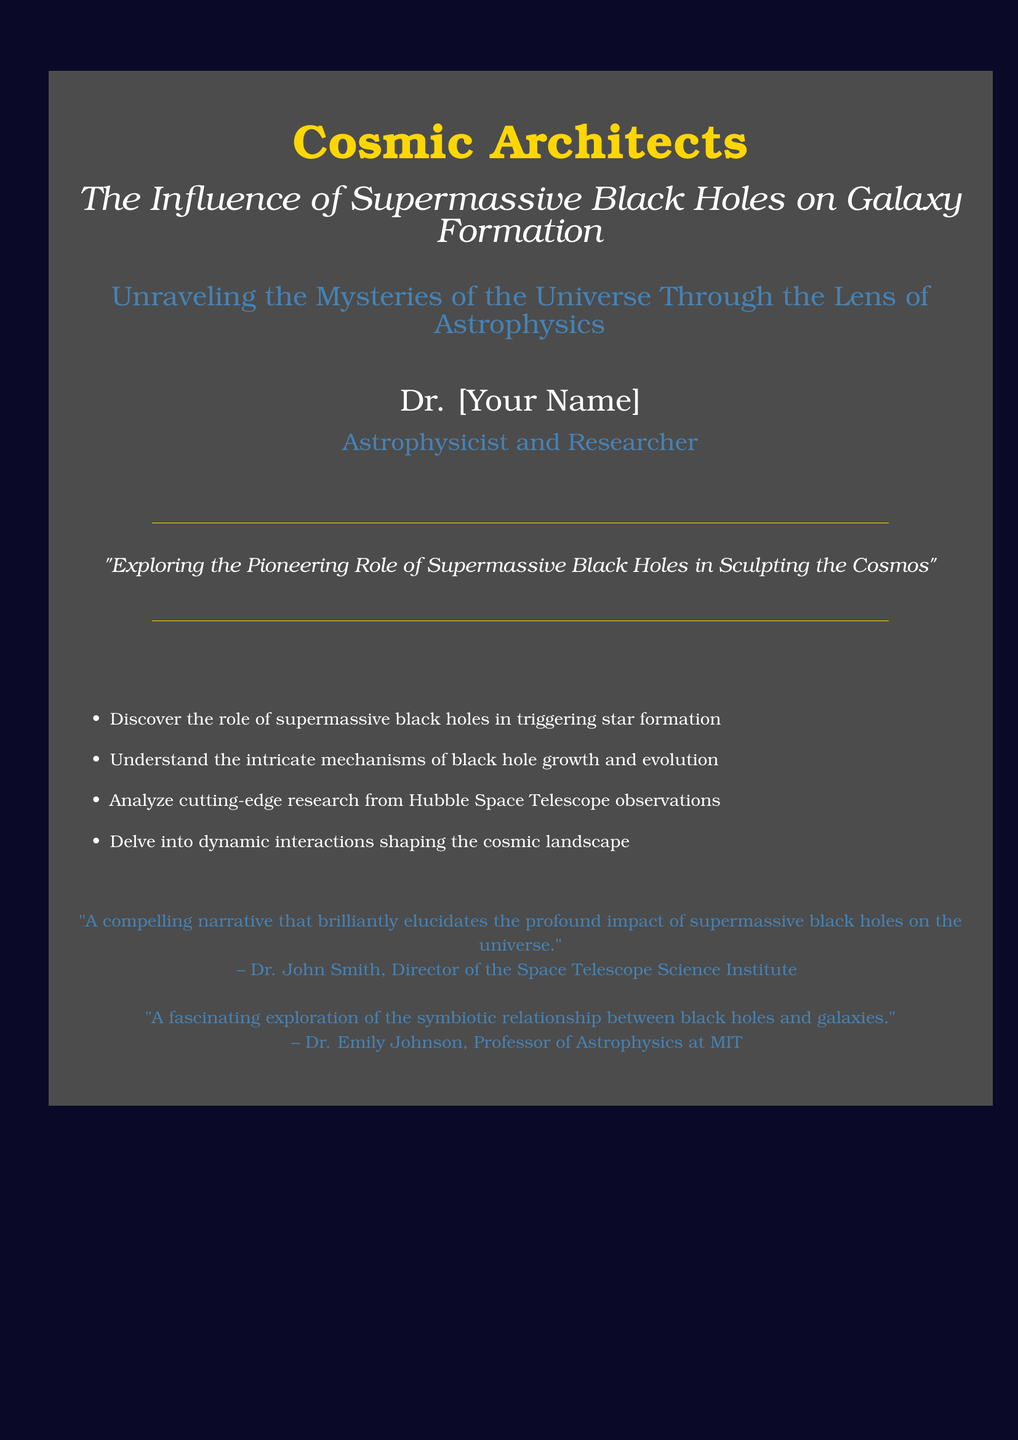What is the title of the book? The title is a prominent feature of the book cover and is displayed in large font.
Answer: Cosmic Architects Who is the author of the book? The author's name is mentioned below the title in a specified format.
Answer: Dr. [Your Name] What is the subtitle of the book? The subtitle provides additional information about the book’s content.
Answer: The Influence of Supermassive Black Holes on Galaxy Formation What is one of the discoveries mentioned in the document? The document lists several key discoveries related to black holes and galaxies.
Answer: The role of supermassive black holes in triggering star formation Who provided a testimonial about the book? The document includes quotes from notable individuals, indicating their views on the book.
Answer: Dr. John Smith What is Dr. John Smith's position? The position of the person providing the testimonial is also mentioned.
Answer: Director of the Space Telescope Science Institute What color is used for the book cover background? Specific colors are applied to enhance the visual appeal of the cover document.
Answer: deepspace Identify a theme explored in the book. The content of the book covers themes related to astrophysics and cosmic phenomena.
Answer: The symbiotic relationship between black holes and galaxies What type of research does the book analyze? The document mentions a focus on particular scientific research conducted through advanced instruments.
Answer: Hubble Space Telescope observations Which color is used for the book’s subtitle? The color of the subtitle is distinct in the design of the book cover.
Answer: white 